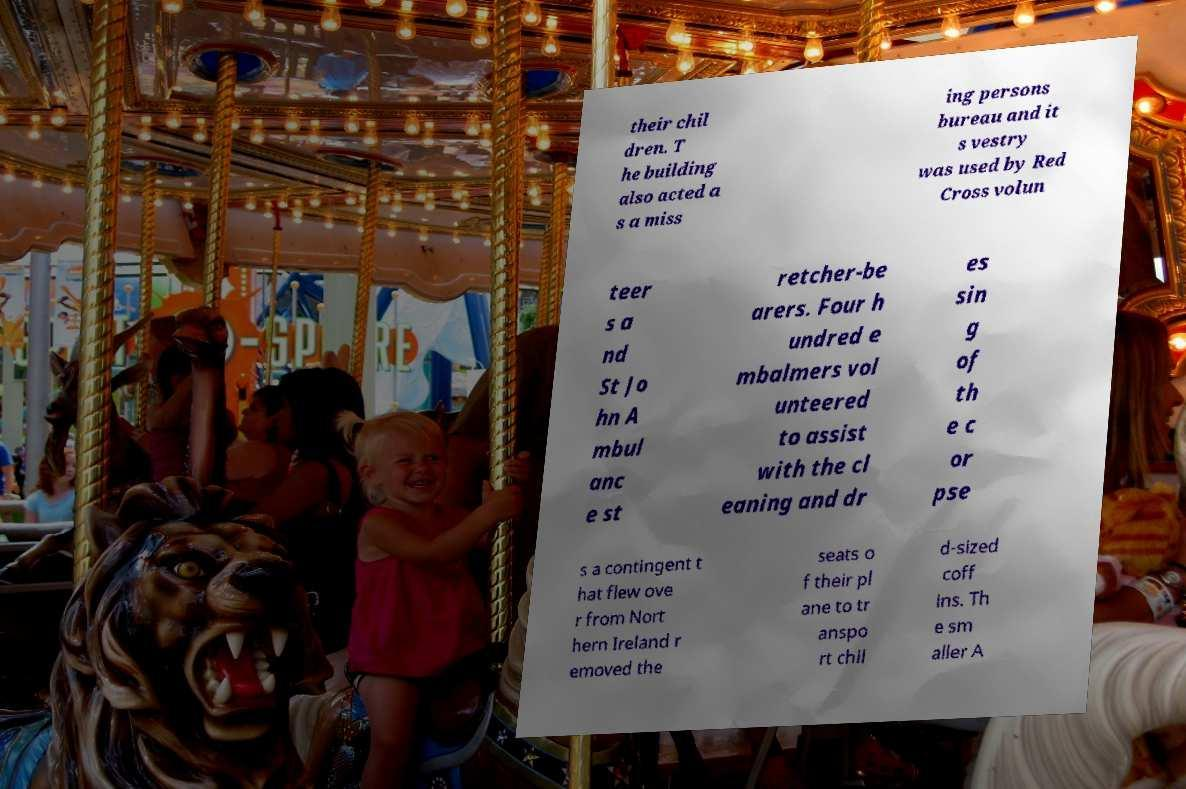Could you extract and type out the text from this image? their chil dren. T he building also acted a s a miss ing persons bureau and it s vestry was used by Red Cross volun teer s a nd St Jo hn A mbul anc e st retcher-be arers. Four h undred e mbalmers vol unteered to assist with the cl eaning and dr es sin g of th e c or pse s a contingent t hat flew ove r from Nort hern Ireland r emoved the seats o f their pl ane to tr anspo rt chil d-sized coff ins. Th e sm aller A 